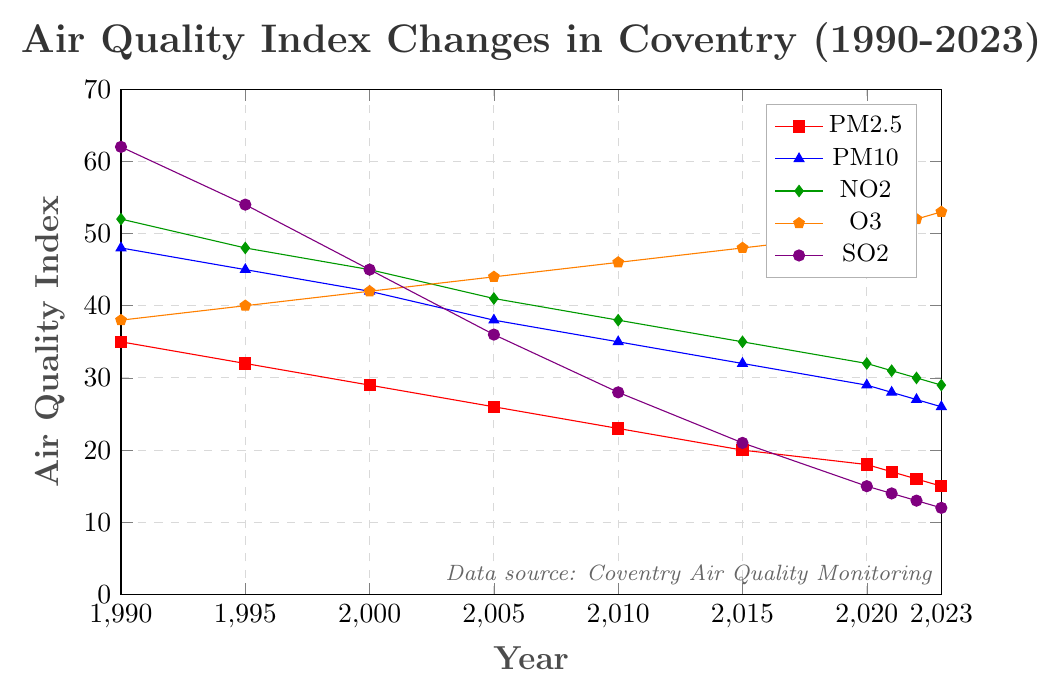How did the PM2.5 levels change from 1990 to 2023? To find the change in PM2.5 levels from 1990 to 2023, look at the initial and final values for the PM2.5 line. In 1990, the PM2.5 level was 35, and in 2023, it was 15. Subtract the final value from the initial value, 35 - 15 = 20.
Answer: 20 Which pollutant showed the most significant decrease from 1990 to 2023? Compare the starting and ending values for each pollutant: PM2.5 (35 to 15), PM10 (48 to 26), NO2 (52 to 29), O3 (38 to 53), and SO2 (62 to 12). The largest decrease is in SO2, which dropped from 62 to 12.
Answer: SO2 What is the average value of NO2 from 1990 to 2023? Sum the NO2 values from each corresponding year: 52 + 48 + 45 + 41 + 38 + 35 + 32 + 31 + 30 + 29 = 381. Divide the total by the number of years: 381 / 10 = 38.1.
Answer: 38.1 Which year did the PM10 level fall below 30? Identify the year when the PM10 level went below 30 by scanning the plot. The value drops below 30 in 2020, with a level of 29.
Answer: 2020 Does O3 follow the same trend as the other pollutants from 1990 to 2023? O3 shows an increasing trend from 1990 (38) to 2023 (53), whereas other pollutants show a decreasing trend.
Answer: No What is the difference between PM2.5 and NO2 levels in 2020? Find the PM2.5 and NO2 values in 2020 (PM2.5: 18, NO2: 32). Subtract the PM2.5 value from the NO2 value: 32 - 18 = 14.
Answer: 14 Compare SO2 levels in 2005 and 2010. Which year had lower levels? Identify the SO2 levels in 2005 (36) and 2010 (28). Since 28 is less than 36, 2010 had lower levels.
Answer: 2010 Did any pollutant's level increase every five years between 1990 and 2023? Examine the trend lines for all pollutants. Only the O3 levels increased consecutively at each 5-year interval.
Answer: O3 During which period did PM2.5 see the most significant drop? Look for the biggest decline in PM2.5 levels between two consecutive points. Between 2010 (23) and 2015 (20), there's a 3-unit drop. However, between 1990 (35) and 1995 (32), there's also a 3-unit drop. Therefore, both periods saw the most significant drop of 3 units.
Answer: 1990-1995 and 2010-2015 